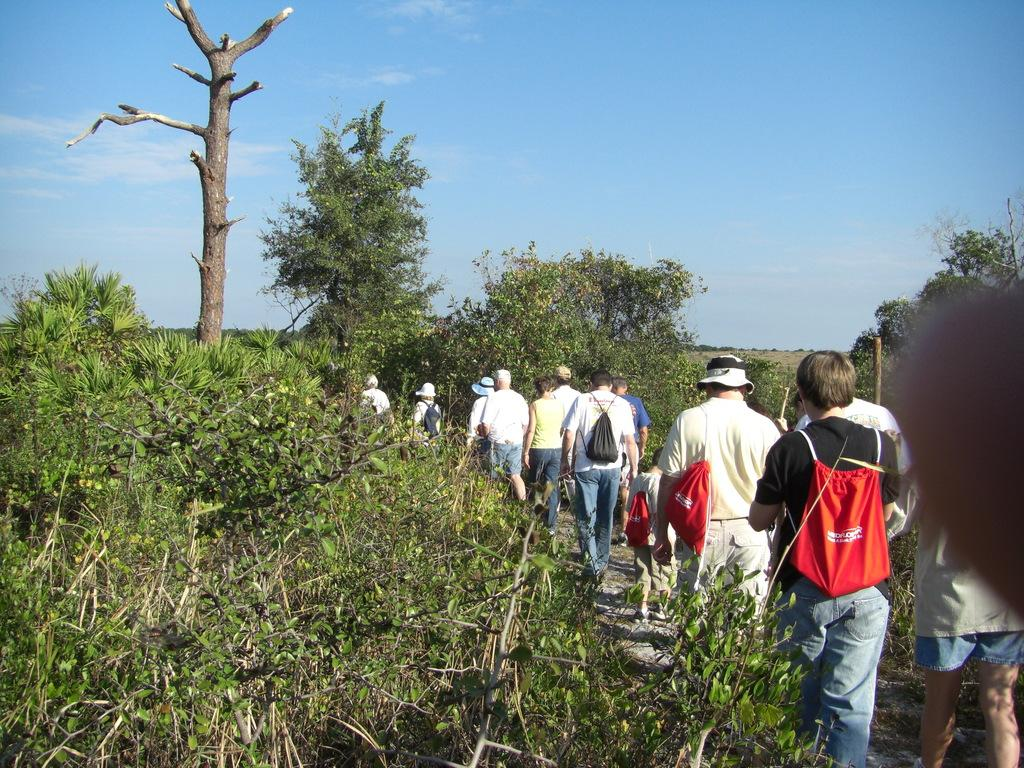What is the main subject of the image? The main subject of the image is a group of people. Where are the people located in the image? The people are on a walkway. What can be seen on both sides of the people? There are trees on the left side and right side of the people. What is visible at the top of the image? The sky is visible at the top of the image. What type of activity is the group of people participating in, and how does it taste? The provided facts do not mention any specific activity the group of people is participating in, nor does it mention any taste. The image only shows a group of people on a walkway with trees on both sides and the sky visible at the top. 